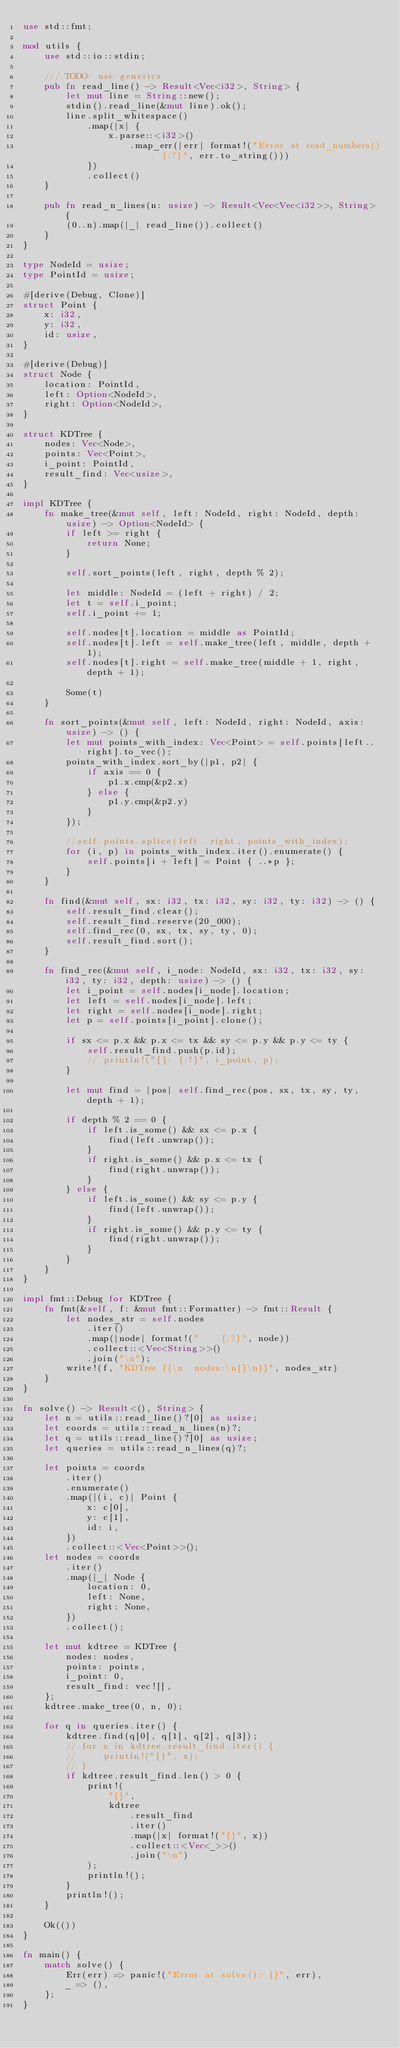<code> <loc_0><loc_0><loc_500><loc_500><_Rust_>use std::fmt;

mod utils {
    use std::io::stdin;

    /// TODO: use generics
    pub fn read_line() -> Result<Vec<i32>, String> {
        let mut line = String::new();
        stdin().read_line(&mut line).ok();
        line.split_whitespace()
            .map(|x| {
                x.parse::<i32>()
                    .map_err(|err| format!("Error at read_numbers(): {:?}", err.to_string()))
            })
            .collect()
    }

    pub fn read_n_lines(n: usize) -> Result<Vec<Vec<i32>>, String> {
        (0..n).map(|_| read_line()).collect()
    }
}

type NodeId = usize;
type PointId = usize;

#[derive(Debug, Clone)]
struct Point {
    x: i32,
    y: i32,
    id: usize,
}

#[derive(Debug)]
struct Node {
    location: PointId,
    left: Option<NodeId>,
    right: Option<NodeId>,
}

struct KDTree {
    nodes: Vec<Node>,
    points: Vec<Point>,
    i_point: PointId,
    result_find: Vec<usize>,
}

impl KDTree {
    fn make_tree(&mut self, left: NodeId, right: NodeId, depth: usize) -> Option<NodeId> {
        if left >= right {
            return None;
        }

        self.sort_points(left, right, depth % 2);

        let middle: NodeId = (left + right) / 2;
        let t = self.i_point;
        self.i_point += 1;

        self.nodes[t].location = middle as PointId;
        self.nodes[t].left = self.make_tree(left, middle, depth + 1);
        self.nodes[t].right = self.make_tree(middle + 1, right, depth + 1);

        Some(t)
    }

    fn sort_points(&mut self, left: NodeId, right: NodeId, axis: usize) -> () {
        let mut points_with_index: Vec<Point> = self.points[left..right].to_vec();
        points_with_index.sort_by(|p1, p2| {
            if axis == 0 {
                p1.x.cmp(&p2.x)
            } else {
                p1.y.cmp(&p2.y)
            }
        });

        //self.points.splice(left..right, points_with_index);
        for (i, p) in points_with_index.iter().enumerate() {
            self.points[i + left] = Point { ..*p };
        }
    }

    fn find(&mut self, sx: i32, tx: i32, sy: i32, ty: i32) -> () {
        self.result_find.clear();
        self.result_find.reserve(20_000);
        self.find_rec(0, sx, tx, sy, ty, 0);
        self.result_find.sort();
    }

    fn find_rec(&mut self, i_node: NodeId, sx: i32, tx: i32, sy: i32, ty: i32, depth: usize) -> () {
        let i_point = self.nodes[i_node].location;
        let left = self.nodes[i_node].left;
        let right = self.nodes[i_node].right;
        let p = self.points[i_point].clone();

        if sx <= p.x && p.x <= tx && sy <= p.y && p.y <= ty {
            self.result_find.push(p.id);
            // println!("{}: {:?}", i_point, p);
        }

        let mut find = |pos| self.find_rec(pos, sx, tx, sy, ty, depth + 1);

        if depth % 2 == 0 {
            if left.is_some() && sx <= p.x {
                find(left.unwrap());
            }
            if right.is_some() && p.x <= tx {
                find(right.unwrap());
            }
        } else {
            if left.is_some() && sy <= p.y {
                find(left.unwrap());
            }
            if right.is_some() && p.y <= ty {
                find(right.unwrap());
            }
        }
    }
}

impl fmt::Debug for KDTree {
    fn fmt(&self, f: &mut fmt::Formatter) -> fmt::Result {
        let nodes_str = self.nodes
            .iter()
            .map(|node| format!("    {:?}", node))
            .collect::<Vec<String>>()
            .join("\n");
        write!(f, "KDTree {{\n  nodes:\n{}\n}}", nodes_str)
    }
}

fn solve() -> Result<(), String> {
    let n = utils::read_line()?[0] as usize;
    let coords = utils::read_n_lines(n)?;
    let q = utils::read_line()?[0] as usize;
    let queries = utils::read_n_lines(q)?;

    let points = coords
        .iter()
        .enumerate()
        .map(|(i, c)| Point {
            x: c[0],
            y: c[1],
            id: i,
        })
        .collect::<Vec<Point>>();
    let nodes = coords
        .iter()
        .map(|_| Node {
            location: 0,
            left: None,
            right: None,
        })
        .collect();

    let mut kdtree = KDTree {
        nodes: nodes,
        points: points,
        i_point: 0,
        result_find: vec![],
    };
    kdtree.make_tree(0, n, 0);

    for q in queries.iter() {
        kdtree.find(q[0], q[1], q[2], q[3]);
        // for x in kdtree.result_find.iter() {
        //     println!("{}", x);
        // }
        if kdtree.result_find.len() > 0 {
            print!(
                "{}",
                kdtree
                    .result_find
                    .iter()
                    .map(|x| format!("{}", x))
                    .collect::<Vec<_>>()
                    .join("\n")
            );
            println!();
        }
        println!();
    }

    Ok(())
}

fn main() {
    match solve() {
        Err(err) => panic!("Error at solve(): {}", err),
        _ => (),
    };
}

</code> 